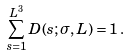<formula> <loc_0><loc_0><loc_500><loc_500>\sum _ { s = 1 } ^ { L ^ { 3 } } D ( s ; \sigma , L ) = 1 \, .</formula> 